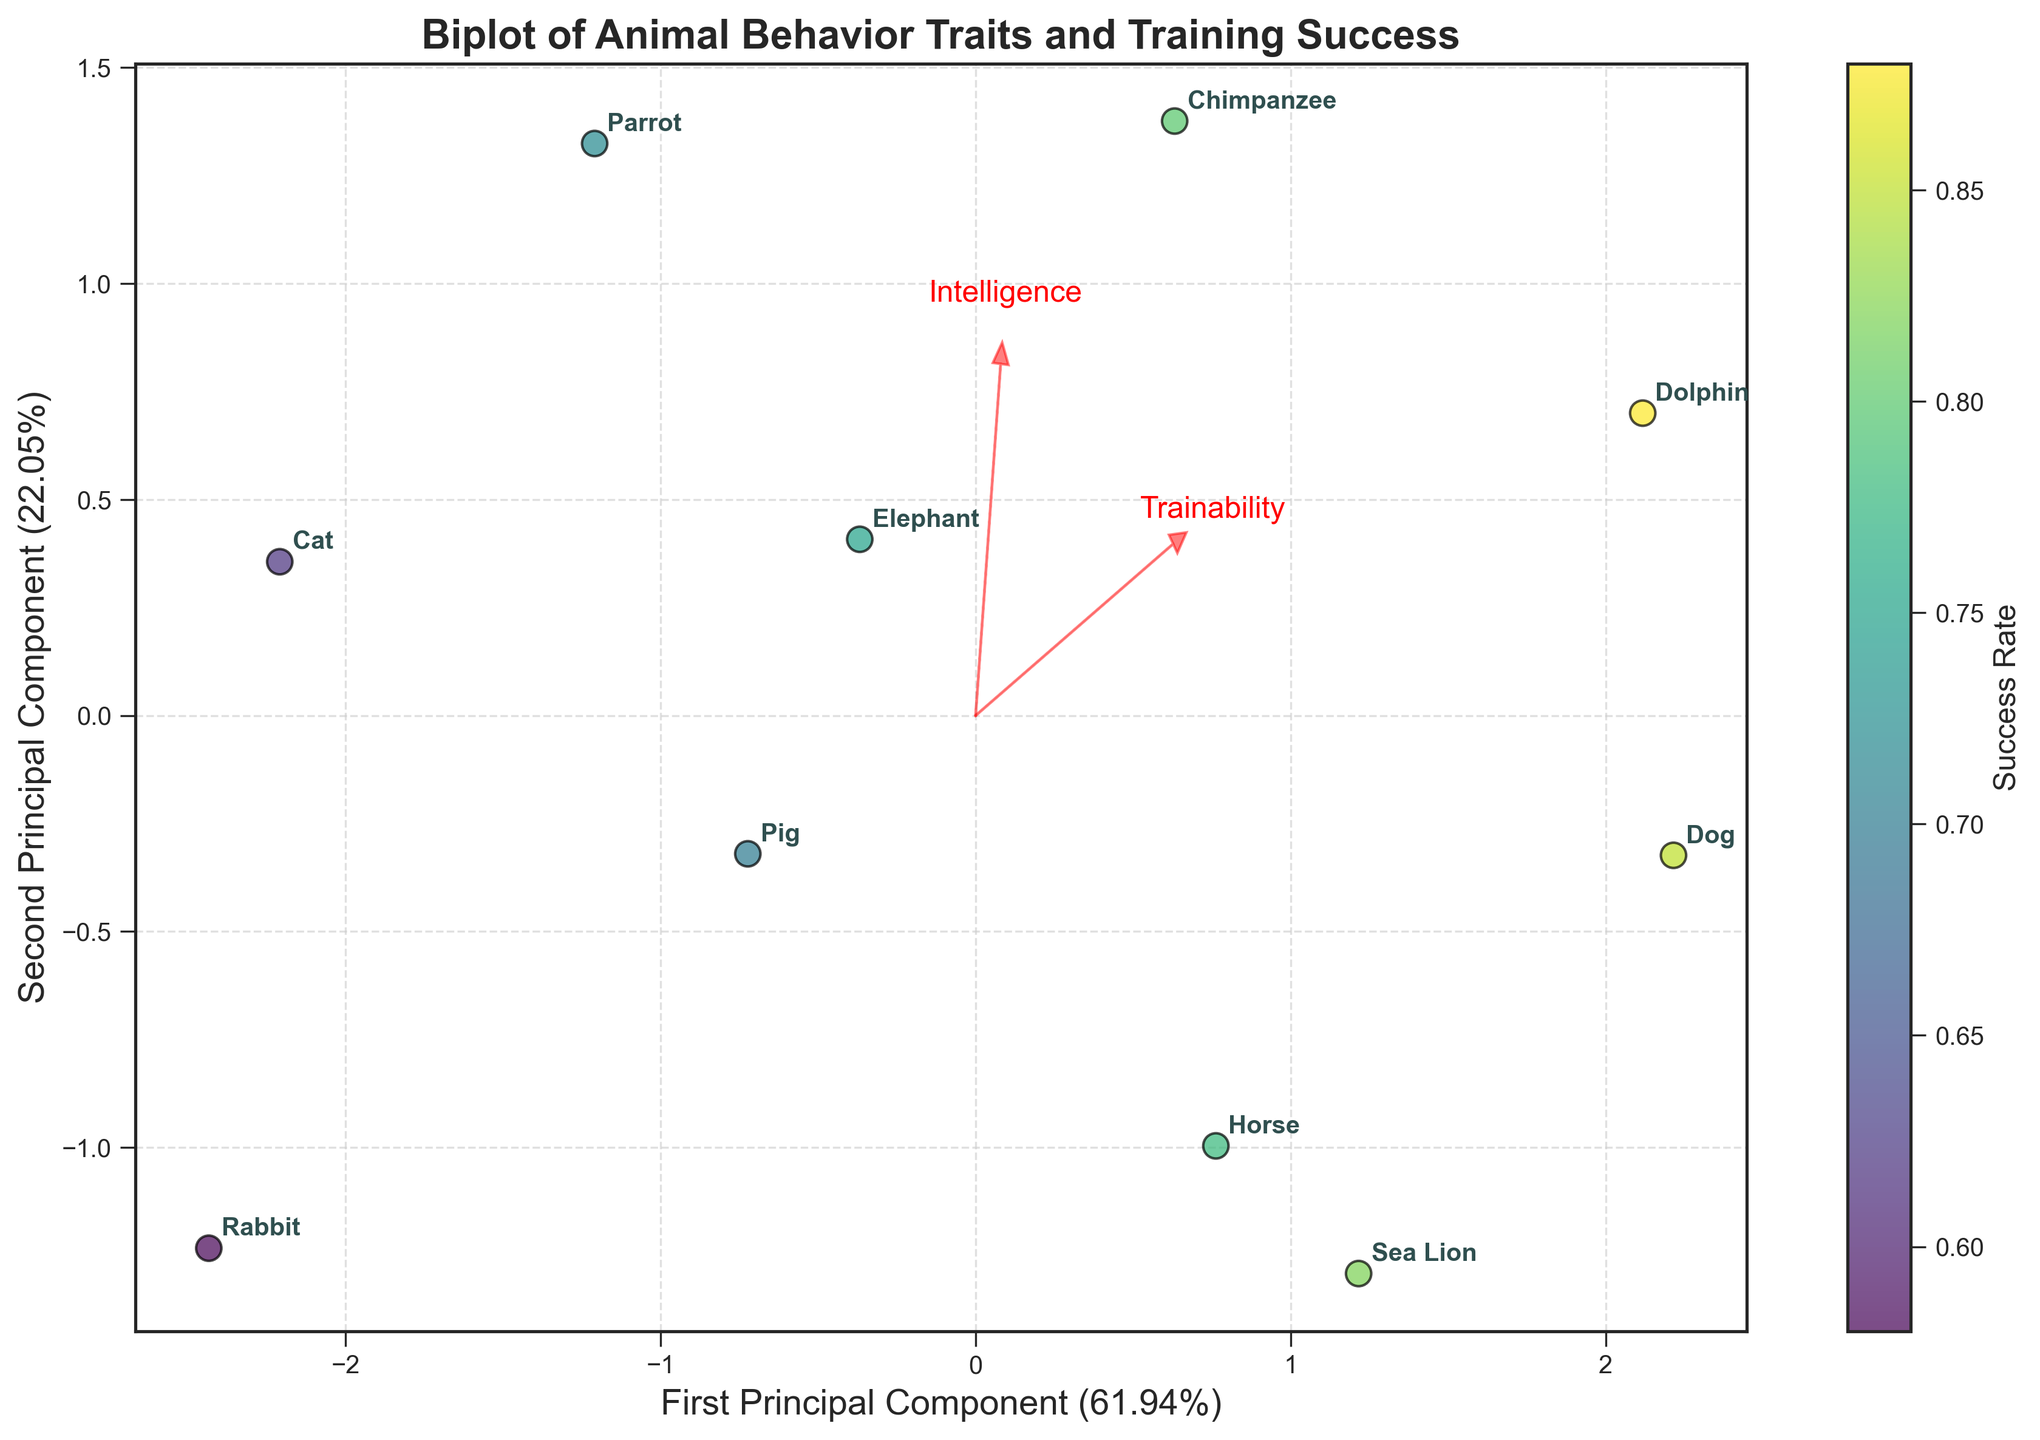What is the title of the figure? The title is usually positioned at the top of the figure. It summarizes what the plot is about. In this case, we can see "Biplot of Animal Behavior Traits and Training Success" at the top.
Answer: Biplot of Animal Behavior Traits and Training Success How many species are represented in the figure? To find the number of species, you can count the number of unique species labels scattered across the plot. By counting the labels, we get 10 species.
Answer: 10 Which species has the highest training success rate? The color coding of the data points represents the training success rate, with lighter colors indicating higher rates. The Dolphin has the lightest color and is annotated in the plot.
Answer: Dolphin Which two traits are the most influential on the first principal component? The feature vectors represented as red arrows indicate the influence of each trait. The traits with the longest arrows along the x-axis (first principal component) are Trainability and Intelligence.
Answer: Trainability and Intelligence Which species is closest to the origin in the plot? The origin is the point (0, 0). The Parrot data point is closest to this origin based on the annotations in the plot.
Answer: Parrot How does the success rate of the Chimpanzee compare to that of the Rabbit? The Chimpanzee is plotted in a lighter color compared to the Rabbit, indicating a higher success rate for the Chimpanzee.
Answer: Chimpanzee has a higher success rate What does the length of the red arrows represent? The length of the red arrows indicates the magnitude of influence of each corresponding trait on the principal components. Longer arrows mean a higher influence.
Answer: Magnitude of influence Which species is associated with high Trainability and high Intelligence? By looking at the plot, species positioned in the direction of the red arrows for high Trainability and Intelligence are Dolphins and Dogs.
Answer: Dolphin and Dog Which two species are plotted farthest apart from each other? Considering the distance between their data points, the Rabbit and Dolphin are the farthest apart in the plot.
Answer: Rabbit and Dolphin Which trait has the least influence on the second principal component? The red arrow with the smallest projection on the y-axis (second principal component) represents the least influence. Sociability has the smallest arrow projection along the y-axis.
Answer: Sociability 